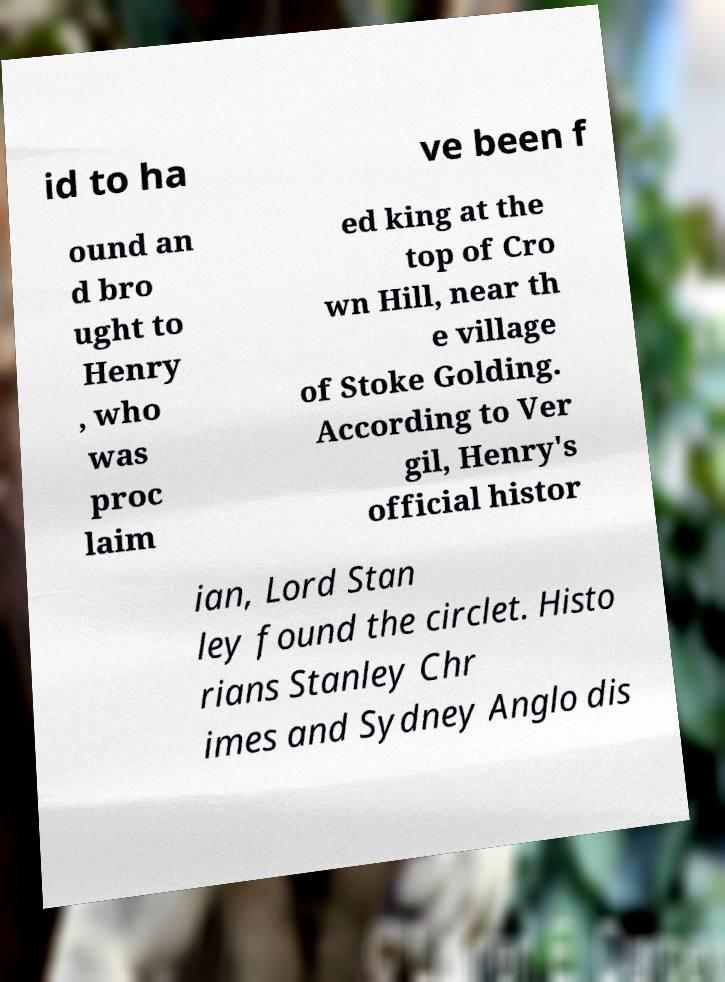Can you accurately transcribe the text from the provided image for me? id to ha ve been f ound an d bro ught to Henry , who was proc laim ed king at the top of Cro wn Hill, near th e village of Stoke Golding. According to Ver gil, Henry's official histor ian, Lord Stan ley found the circlet. Histo rians Stanley Chr imes and Sydney Anglo dis 